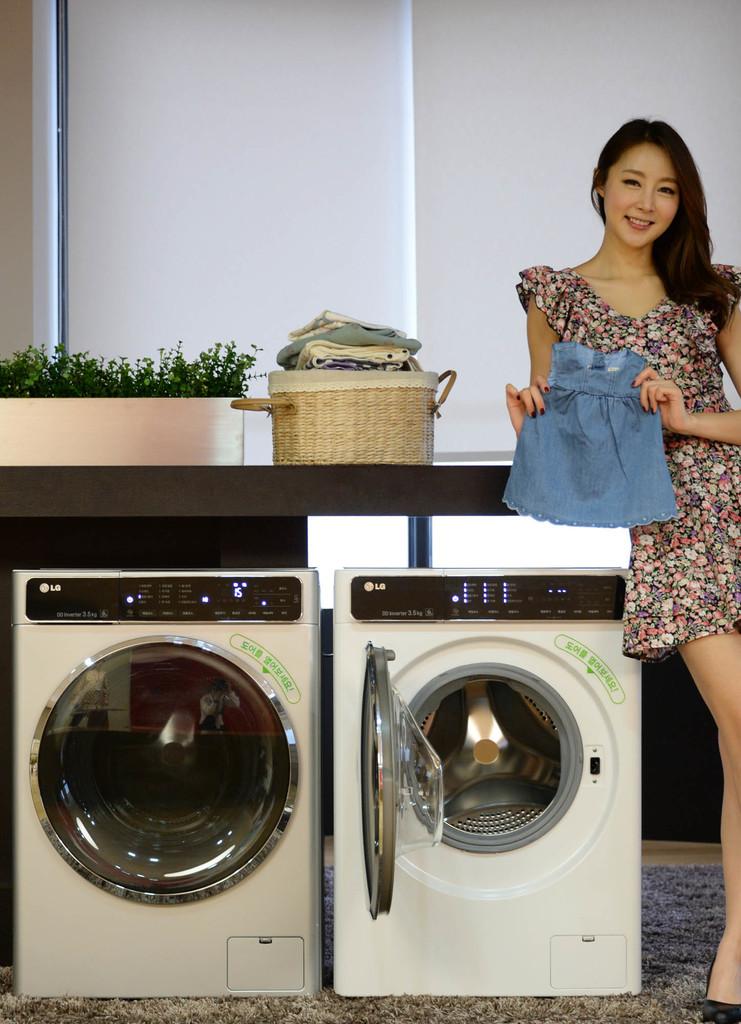What brand is the washing machine?
Your answer should be compact. Lg. This is a washing machine this using to the cloth washing?
Ensure brevity in your answer.  Yes. 